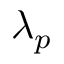Convert formula to latex. <formula><loc_0><loc_0><loc_500><loc_500>\lambda _ { p }</formula> 